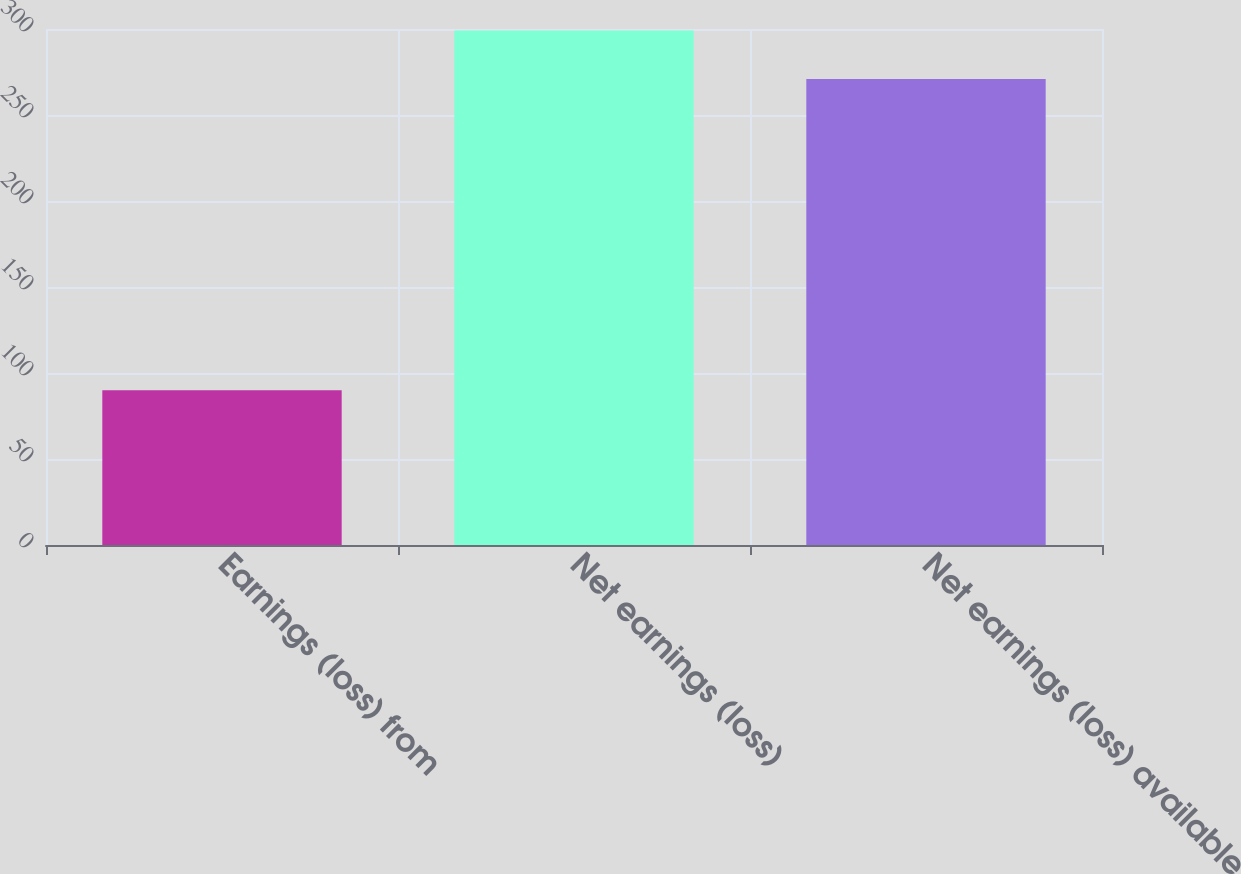Convert chart. <chart><loc_0><loc_0><loc_500><loc_500><bar_chart><fcel>Earnings (loss) from<fcel>Net earnings (loss)<fcel>Net earnings (loss) available<nl><fcel>90<fcel>299.1<fcel>271<nl></chart> 